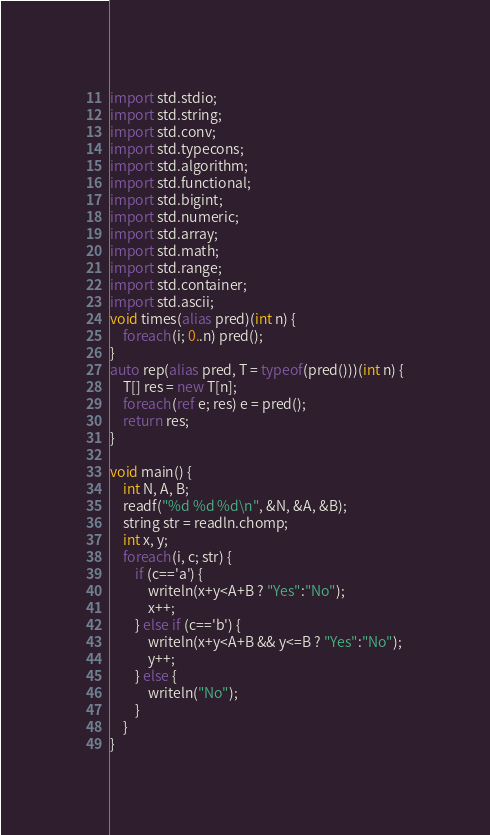Convert code to text. <code><loc_0><loc_0><loc_500><loc_500><_D_>import std.stdio;
import std.string;
import std.conv;
import std.typecons;
import std.algorithm;
import std.functional;
import std.bigint;
import std.numeric;
import std.array;
import std.math;
import std.range;
import std.container;
import std.ascii;
void times(alias pred)(int n) {
    foreach(i; 0..n) pred();
}
auto rep(alias pred, T = typeof(pred()))(int n) {
    T[] res = new T[n];
    foreach(ref e; res) e = pred();
    return res;
}

void main() {
    int N, A, B;
    readf("%d %d %d\n", &N, &A, &B);
    string str = readln.chomp;
    int x, y;
    foreach(i, c; str) {
        if (c=='a') {
            writeln(x+y<A+B ? "Yes":"No");
            x++;
        } else if (c=='b') {
            writeln(x+y<A+B && y<=B ? "Yes":"No");
            y++;
        } else {
            writeln("No");
        }
    }
}
</code> 